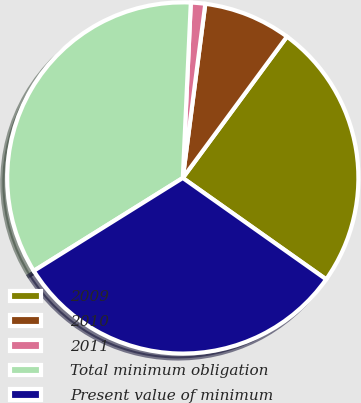Convert chart. <chart><loc_0><loc_0><loc_500><loc_500><pie_chart><fcel>2009<fcel>2010<fcel>2011<fcel>Total minimum obligation<fcel>Present value of minimum<nl><fcel>24.69%<fcel>8.06%<fcel>1.32%<fcel>34.6%<fcel>31.33%<nl></chart> 